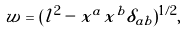Convert formula to latex. <formula><loc_0><loc_0><loc_500><loc_500>w = ( l ^ { 2 } - x ^ { a } x ^ { b } \delta _ { a b } ) ^ { 1 / 2 } ,</formula> 